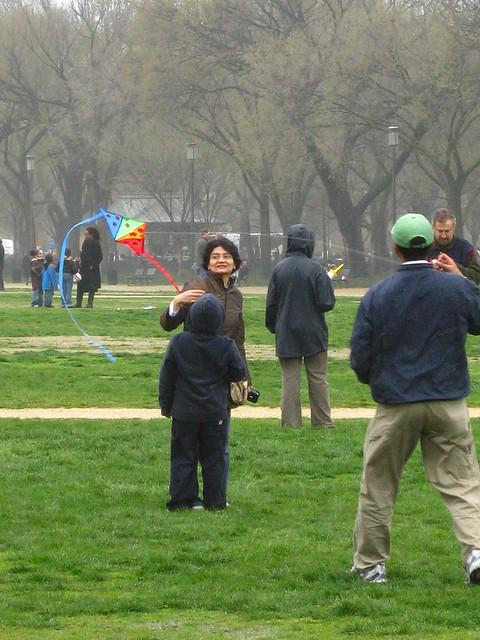Who is steering the flying object? man 